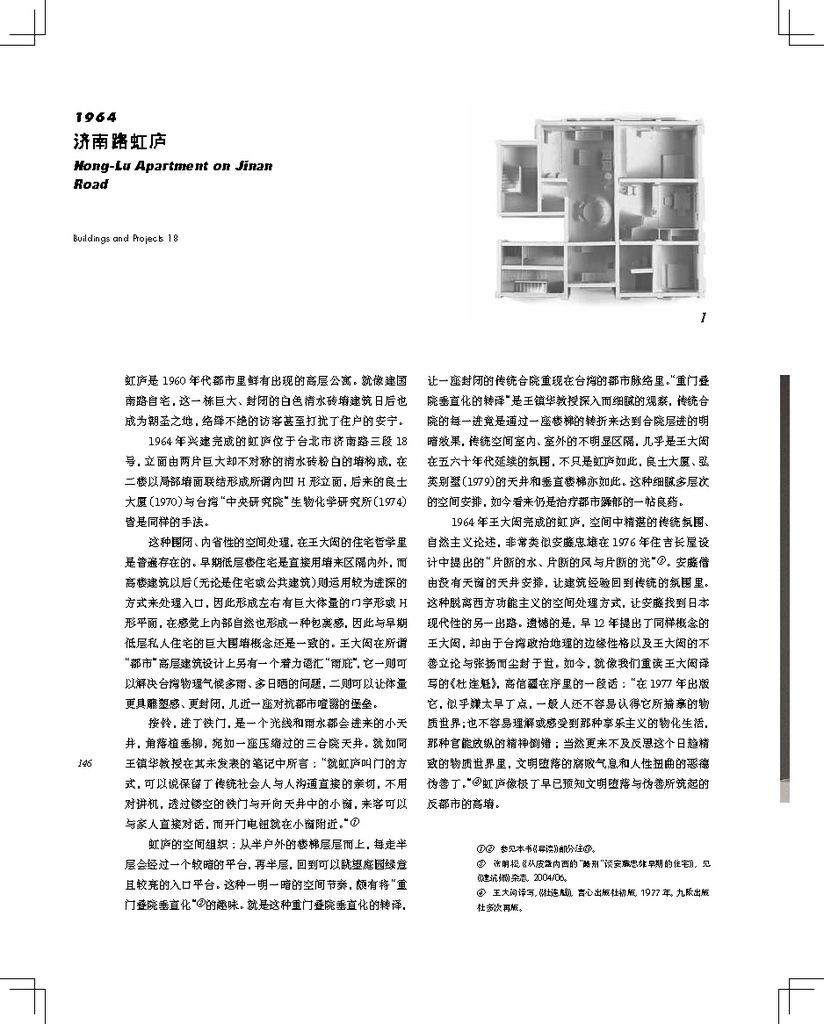Provide a one-sentence caption for the provided image. A white piece of paper describing the floor plan for Hong Lu apartment. 